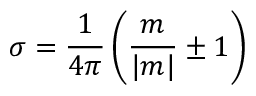<formula> <loc_0><loc_0><loc_500><loc_500>\sigma = \frac { 1 } 4 \pi } \left ( \frac { m } | m | } \pm 1 \right )</formula> 